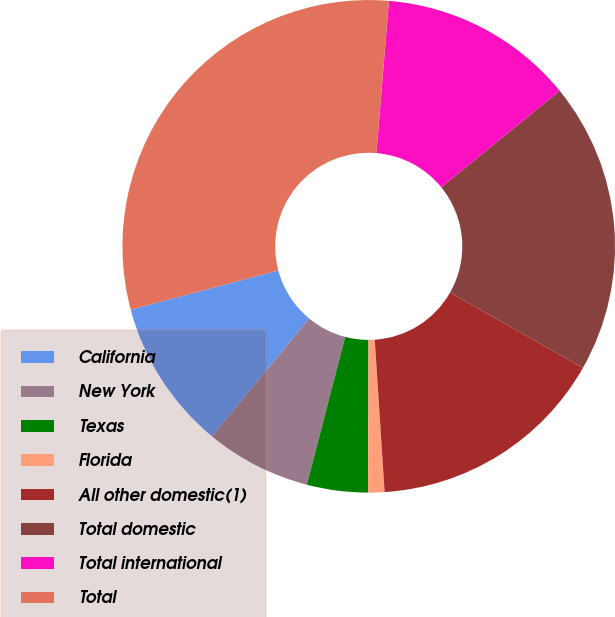Convert chart to OTSL. <chart><loc_0><loc_0><loc_500><loc_500><pie_chart><fcel>California<fcel>New York<fcel>Texas<fcel>Florida<fcel>All other domestic(1)<fcel>Total domestic<fcel>Total international<fcel>Total<nl><fcel>9.88%<fcel>6.94%<fcel>4.0%<fcel>1.07%<fcel>15.76%<fcel>19.09%<fcel>12.82%<fcel>30.45%<nl></chart> 